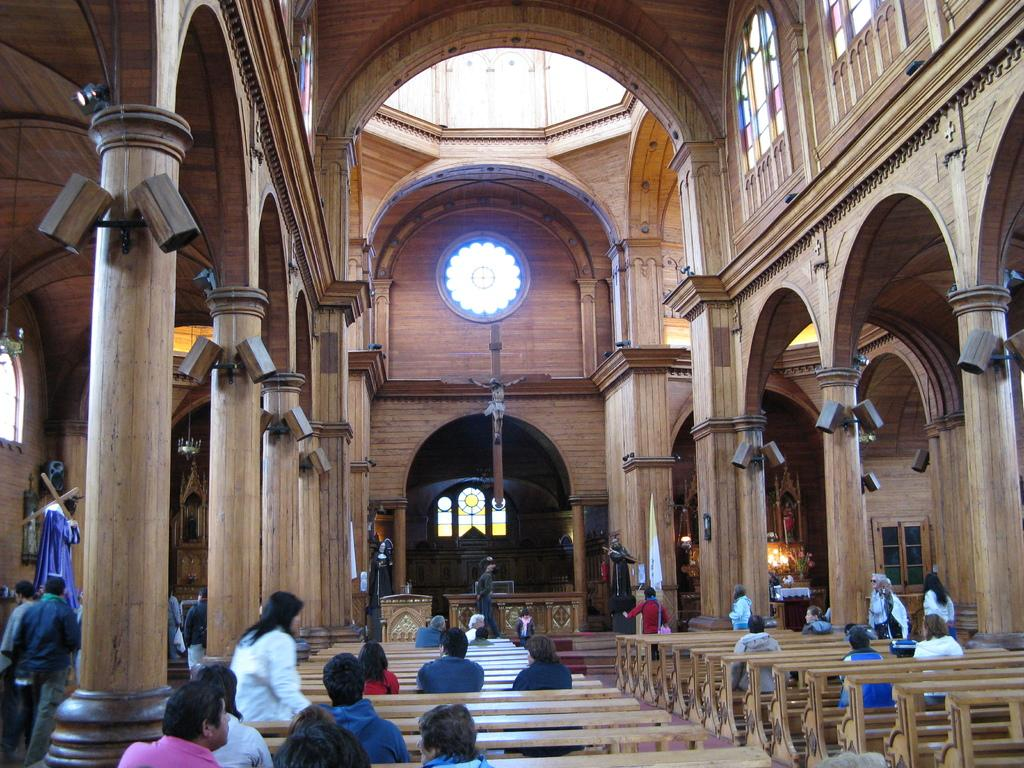What type of building is shown in the image? The image is an inside view of a church. What are the people in the image doing? The people in the image are sitting on benches. What can be seen on the floor in the image? The floor is visible in the image. What type of decorative elements can be seen in the image? Sculptures and pillars are present in the image. What is providing light in the image? Lights are visible in the image. What architectural feature allows natural light to enter the church? Windows are present in the image. Is there a writer sitting at a desk in the image? There is no writer or desk present in the image. Can you see any pipes in the image? There are no pipes visible in the image. 